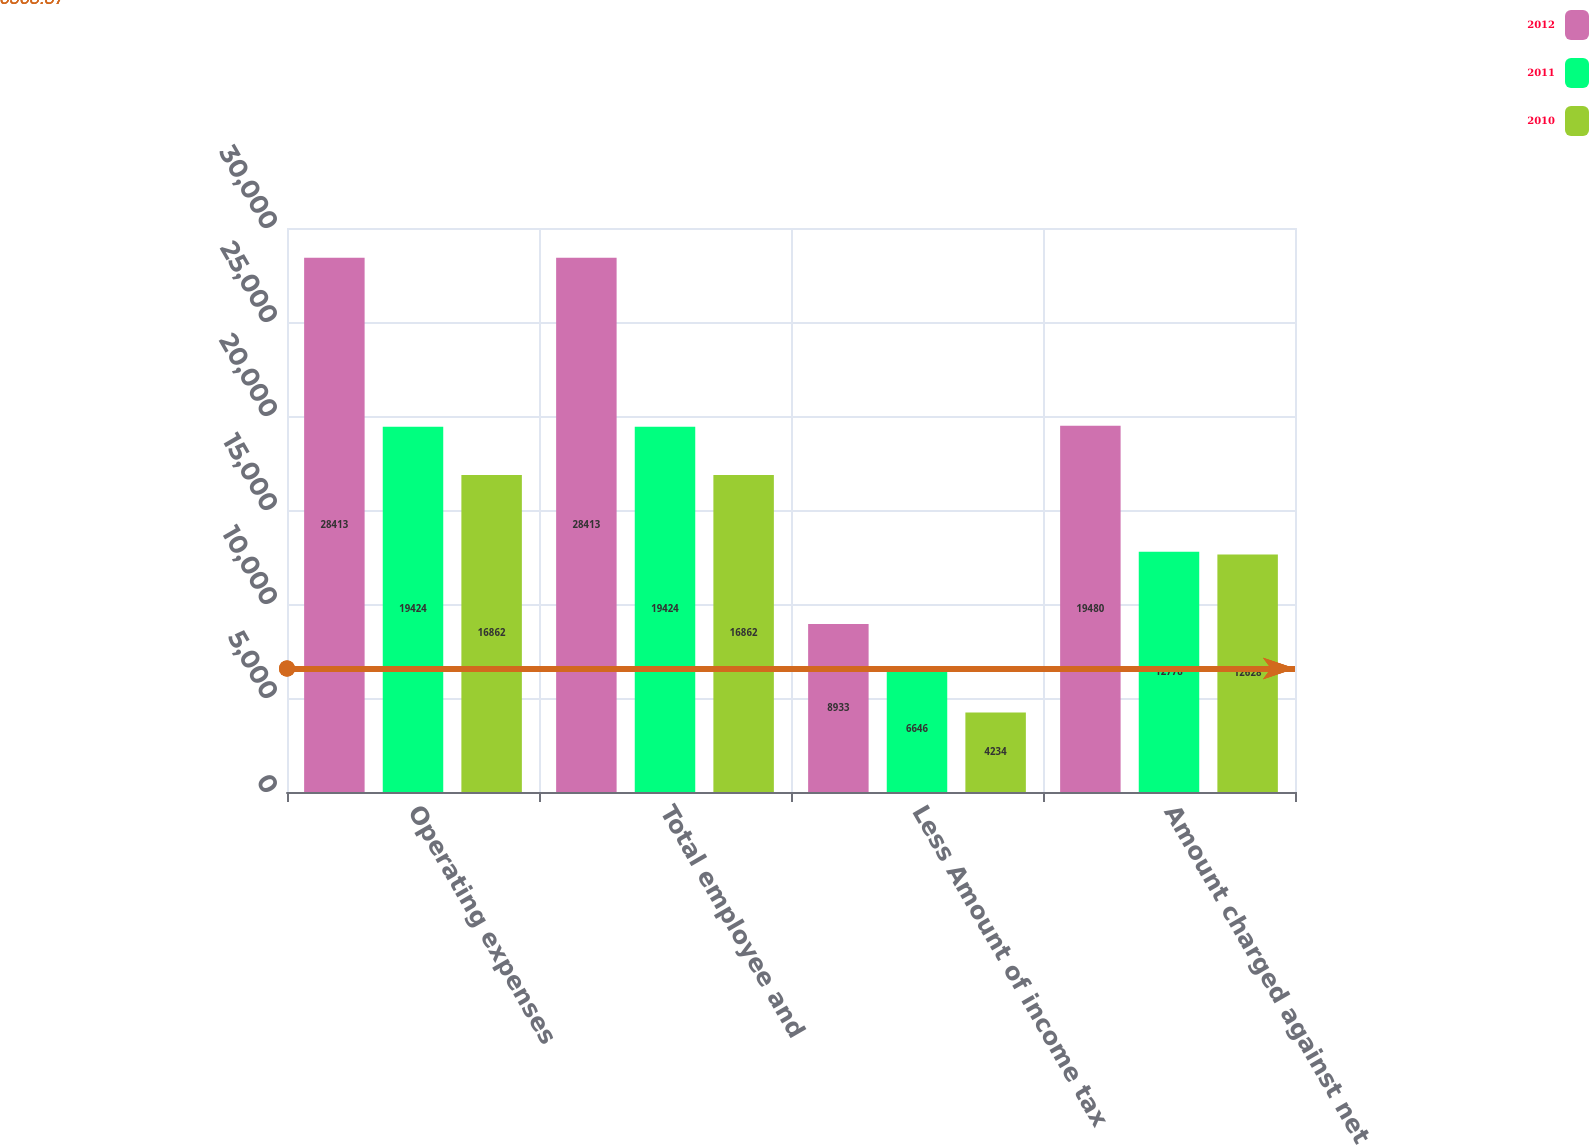Convert chart. <chart><loc_0><loc_0><loc_500><loc_500><stacked_bar_chart><ecel><fcel>Operating expenses<fcel>Total employee and<fcel>Less Amount of income tax<fcel>Amount charged against net<nl><fcel>2012<fcel>28413<fcel>28413<fcel>8933<fcel>19480<nl><fcel>2011<fcel>19424<fcel>19424<fcel>6646<fcel>12778<nl><fcel>2010<fcel>16862<fcel>16862<fcel>4234<fcel>12628<nl></chart> 